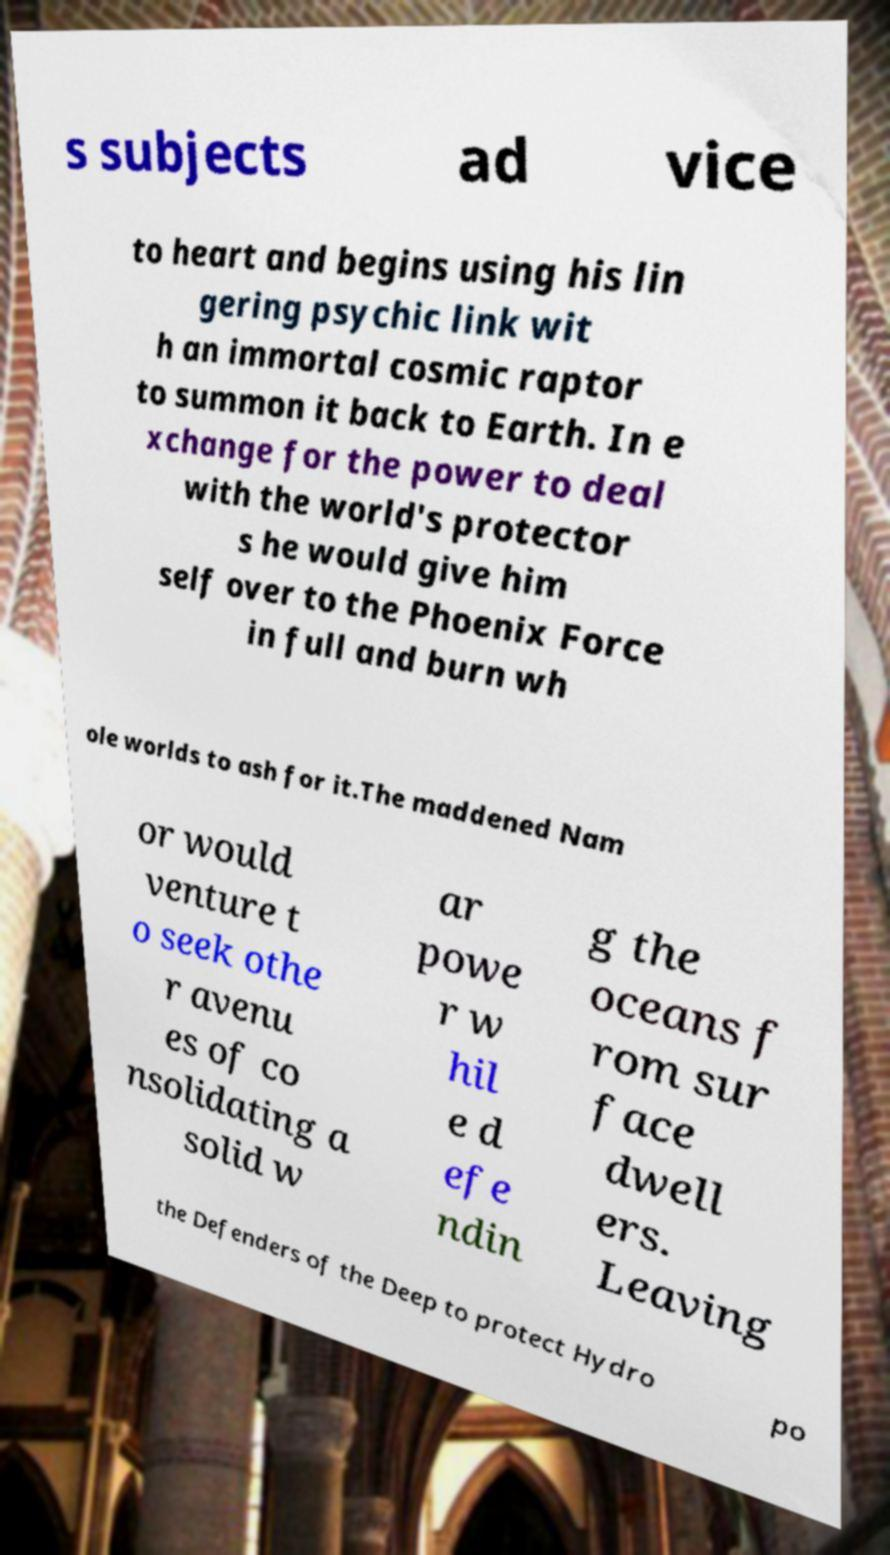Please identify and transcribe the text found in this image. s subjects ad vice to heart and begins using his lin gering psychic link wit h an immortal cosmic raptor to summon it back to Earth. In e xchange for the power to deal with the world's protector s he would give him self over to the Phoenix Force in full and burn wh ole worlds to ash for it.The maddened Nam or would venture t o seek othe r avenu es of co nsolidating a solid w ar powe r w hil e d efe ndin g the oceans f rom sur face dwell ers. Leaving the Defenders of the Deep to protect Hydro po 